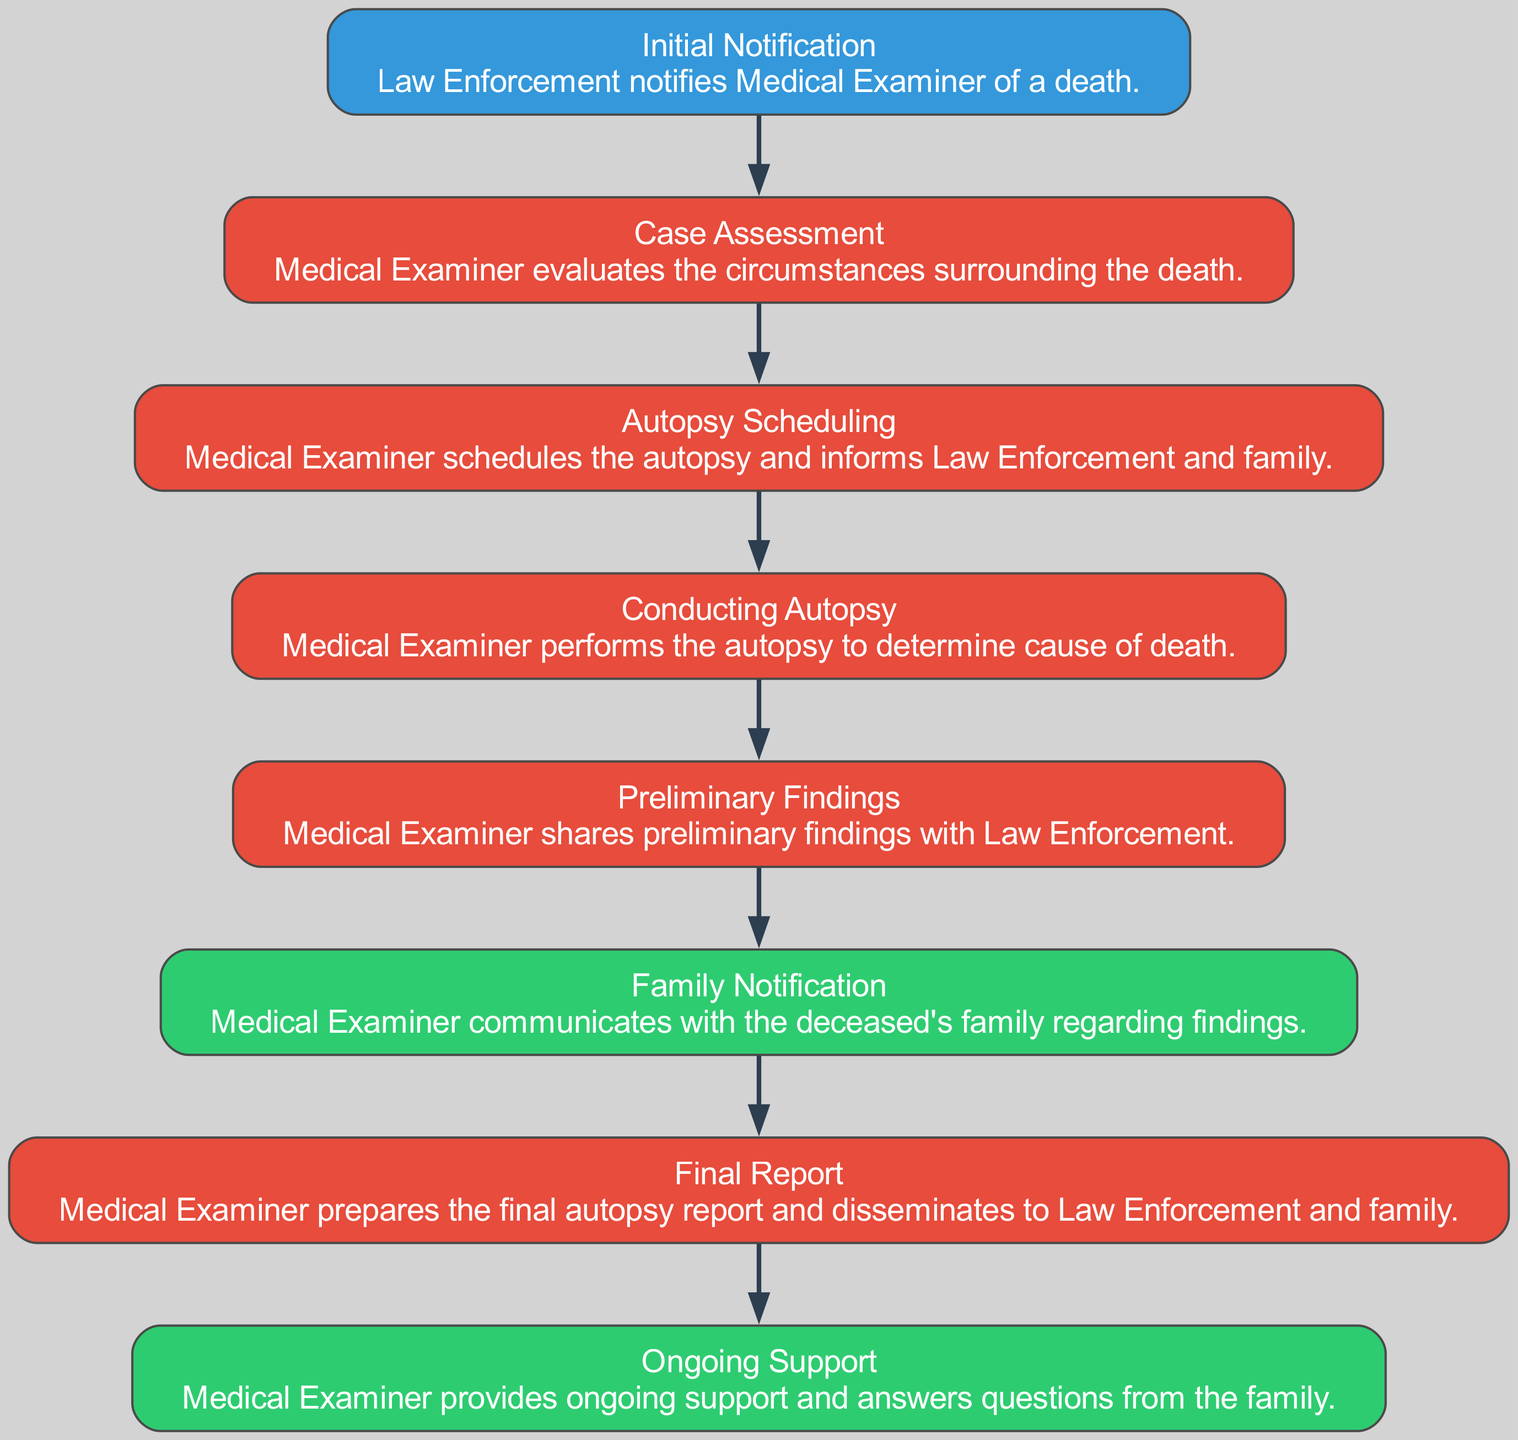What is the first step in the flow of communication? The first step listed in the diagram is "Initial Notification," where Law Enforcement notifies the Medical Examiner of a death.
Answer: Initial Notification How many main steps are involved in the communication flow? The diagram outlines a total of eight main steps in the flow of communication between the Medical Examiner, Law Enforcement, and the family.
Answer: Eight Which actor is responsible for conducting the autopsy? The node "Conducting Autopsy" is primarily associated with the Medical Examiner, who performs the autopsy to determine the cause of death.
Answer: Medical Examiner What is shared with Law Enforcement after the autopsy is conducted? After conducting the autopsy, the Medical Examiner shares "Preliminary Findings" with Law Enforcement to inform them about the initial outcomes of the examination.
Answer: Preliminary Findings What step follows the "Family Notification"? The step that follows "Family Notification" is "Final Report," where the Medical Examiner prepares the final autopsy report and disseminates it to Law Enforcement and family.
Answer: Final Report How does the Medical Examiner assist the family after final findings? After providing the final report, the Medical Examiner offers "Ongoing Support" to the family, answering any questions or providing additional assistance as needed.
Answer: Ongoing Support What relationship exists between "Autopsy Scheduling" and "Conducting Autopsy"? The "Autopsy Scheduling" step directly precedes the "Conducting Autopsy" step in the flow, indicating that scheduling must occur before the autopsy can be performed.
Answer: Precedes Which two actors are involved in the "Family Notification" step? The "Family Notification" step involves both the Medical Examiner and the deceased's family, as the Medical Examiner communicates findings to the family.
Answer: Medical Examiner and Family What is the role of Law Enforcement in the communication flow? Law Enforcement initiates the process by notifying the Medical Examiner of a death and is involved in the communication of findings throughout the process.
Answer: Initiator and Collaborator 